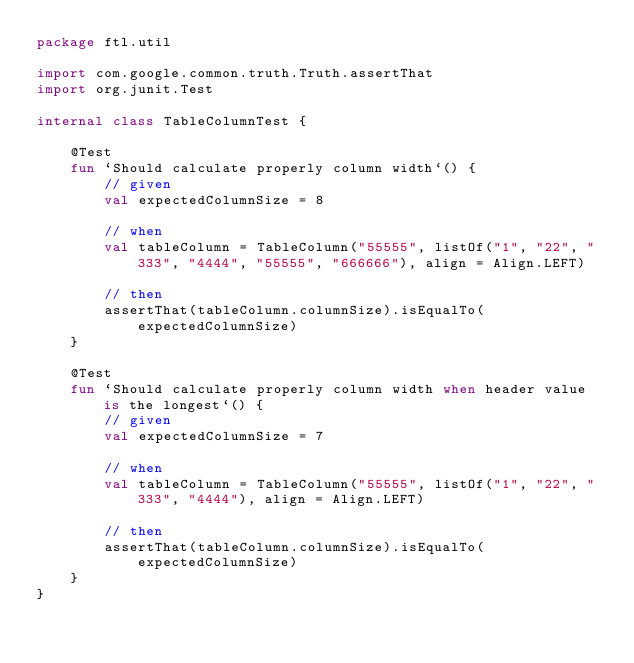<code> <loc_0><loc_0><loc_500><loc_500><_Kotlin_>package ftl.util

import com.google.common.truth.Truth.assertThat
import org.junit.Test

internal class TableColumnTest {

    @Test
    fun `Should calculate properly column width`() {
        // given
        val expectedColumnSize = 8

        // when
        val tableColumn = TableColumn("55555", listOf("1", "22", "333", "4444", "55555", "666666"), align = Align.LEFT)

        // then
        assertThat(tableColumn.columnSize).isEqualTo(expectedColumnSize)
    }

    @Test
    fun `Should calculate properly column width when header value is the longest`() {
        // given
        val expectedColumnSize = 7

        // when
        val tableColumn = TableColumn("55555", listOf("1", "22", "333", "4444"), align = Align.LEFT)

        // then
        assertThat(tableColumn.columnSize).isEqualTo(expectedColumnSize)
    }
}
</code> 